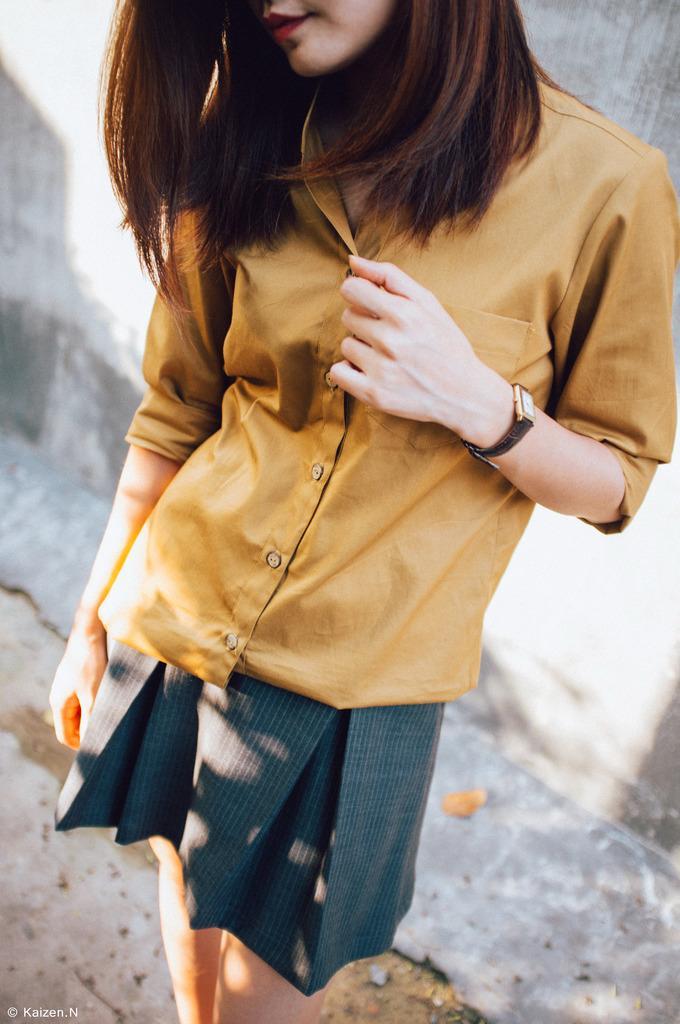In one or two sentences, can you explain what this image depicts? In this image we can see a woman standing on the ground. On the backside we can see a wall. 